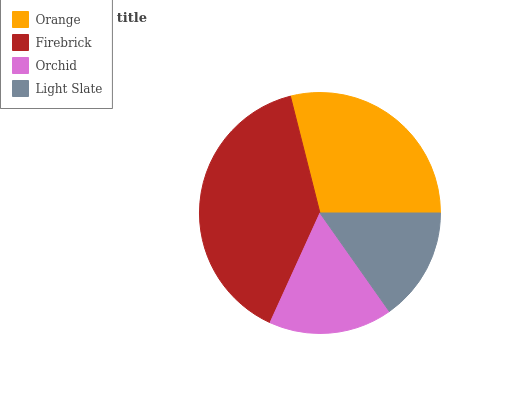Is Light Slate the minimum?
Answer yes or no. Yes. Is Firebrick the maximum?
Answer yes or no. Yes. Is Orchid the minimum?
Answer yes or no. No. Is Orchid the maximum?
Answer yes or no. No. Is Firebrick greater than Orchid?
Answer yes or no. Yes. Is Orchid less than Firebrick?
Answer yes or no. Yes. Is Orchid greater than Firebrick?
Answer yes or no. No. Is Firebrick less than Orchid?
Answer yes or no. No. Is Orange the high median?
Answer yes or no. Yes. Is Orchid the low median?
Answer yes or no. Yes. Is Orchid the high median?
Answer yes or no. No. Is Firebrick the low median?
Answer yes or no. No. 